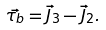<formula> <loc_0><loc_0><loc_500><loc_500>\vec { \tau _ { b } } = \vec { J } _ { 3 } - \vec { J } _ { 2 } .</formula> 